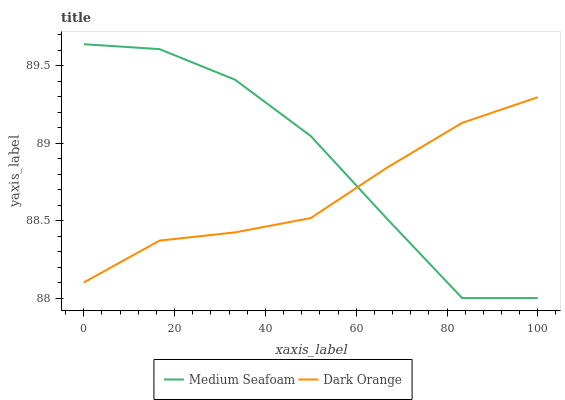Does Dark Orange have the minimum area under the curve?
Answer yes or no. Yes. Does Medium Seafoam have the maximum area under the curve?
Answer yes or no. Yes. Does Medium Seafoam have the minimum area under the curve?
Answer yes or no. No. Is Dark Orange the smoothest?
Answer yes or no. Yes. Is Medium Seafoam the roughest?
Answer yes or no. Yes. Is Medium Seafoam the smoothest?
Answer yes or no. No. Does Medium Seafoam have the lowest value?
Answer yes or no. Yes. Does Medium Seafoam have the highest value?
Answer yes or no. Yes. Does Dark Orange intersect Medium Seafoam?
Answer yes or no. Yes. Is Dark Orange less than Medium Seafoam?
Answer yes or no. No. Is Dark Orange greater than Medium Seafoam?
Answer yes or no. No. 